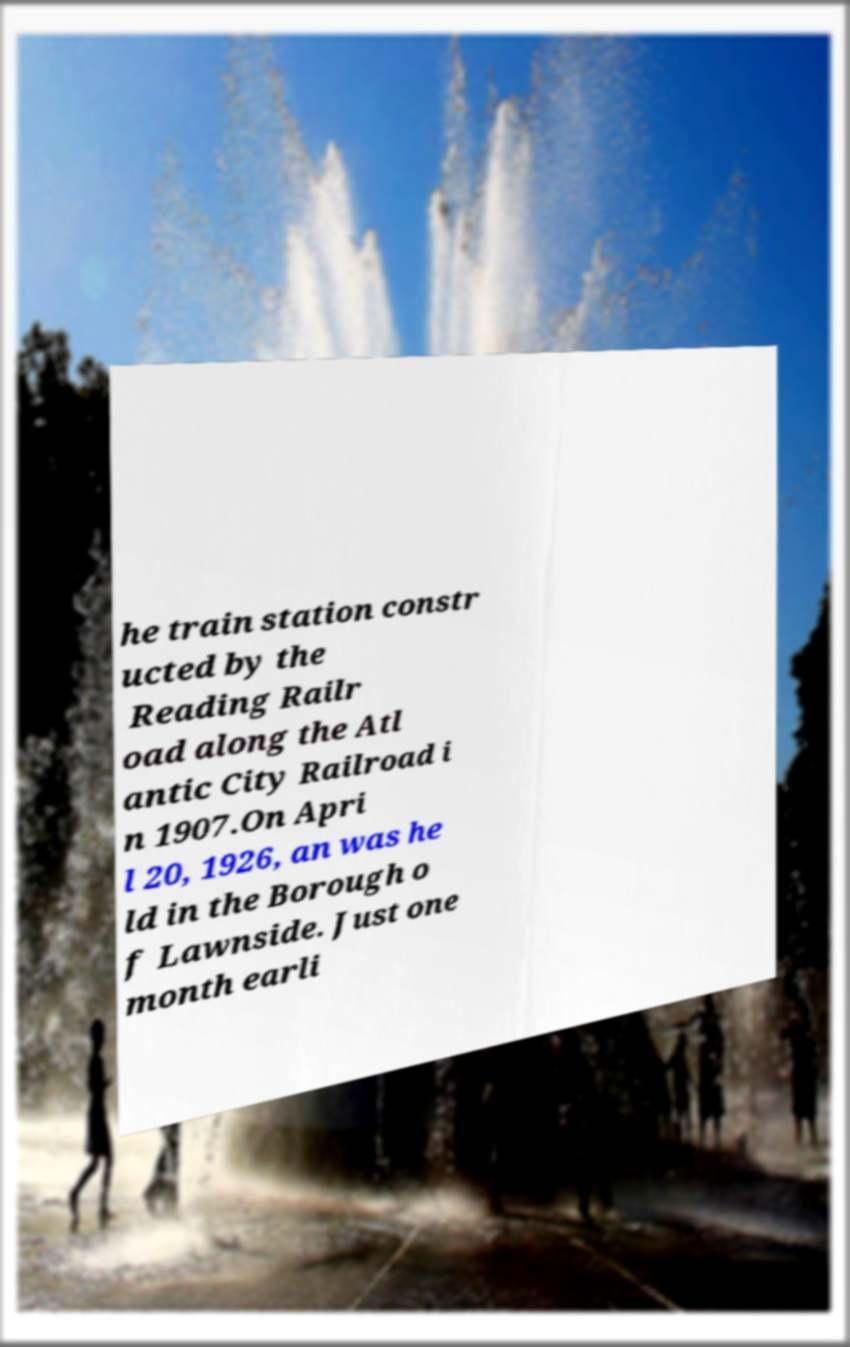Can you accurately transcribe the text from the provided image for me? he train station constr ucted by the Reading Railr oad along the Atl antic City Railroad i n 1907.On Apri l 20, 1926, an was he ld in the Borough o f Lawnside. Just one month earli 